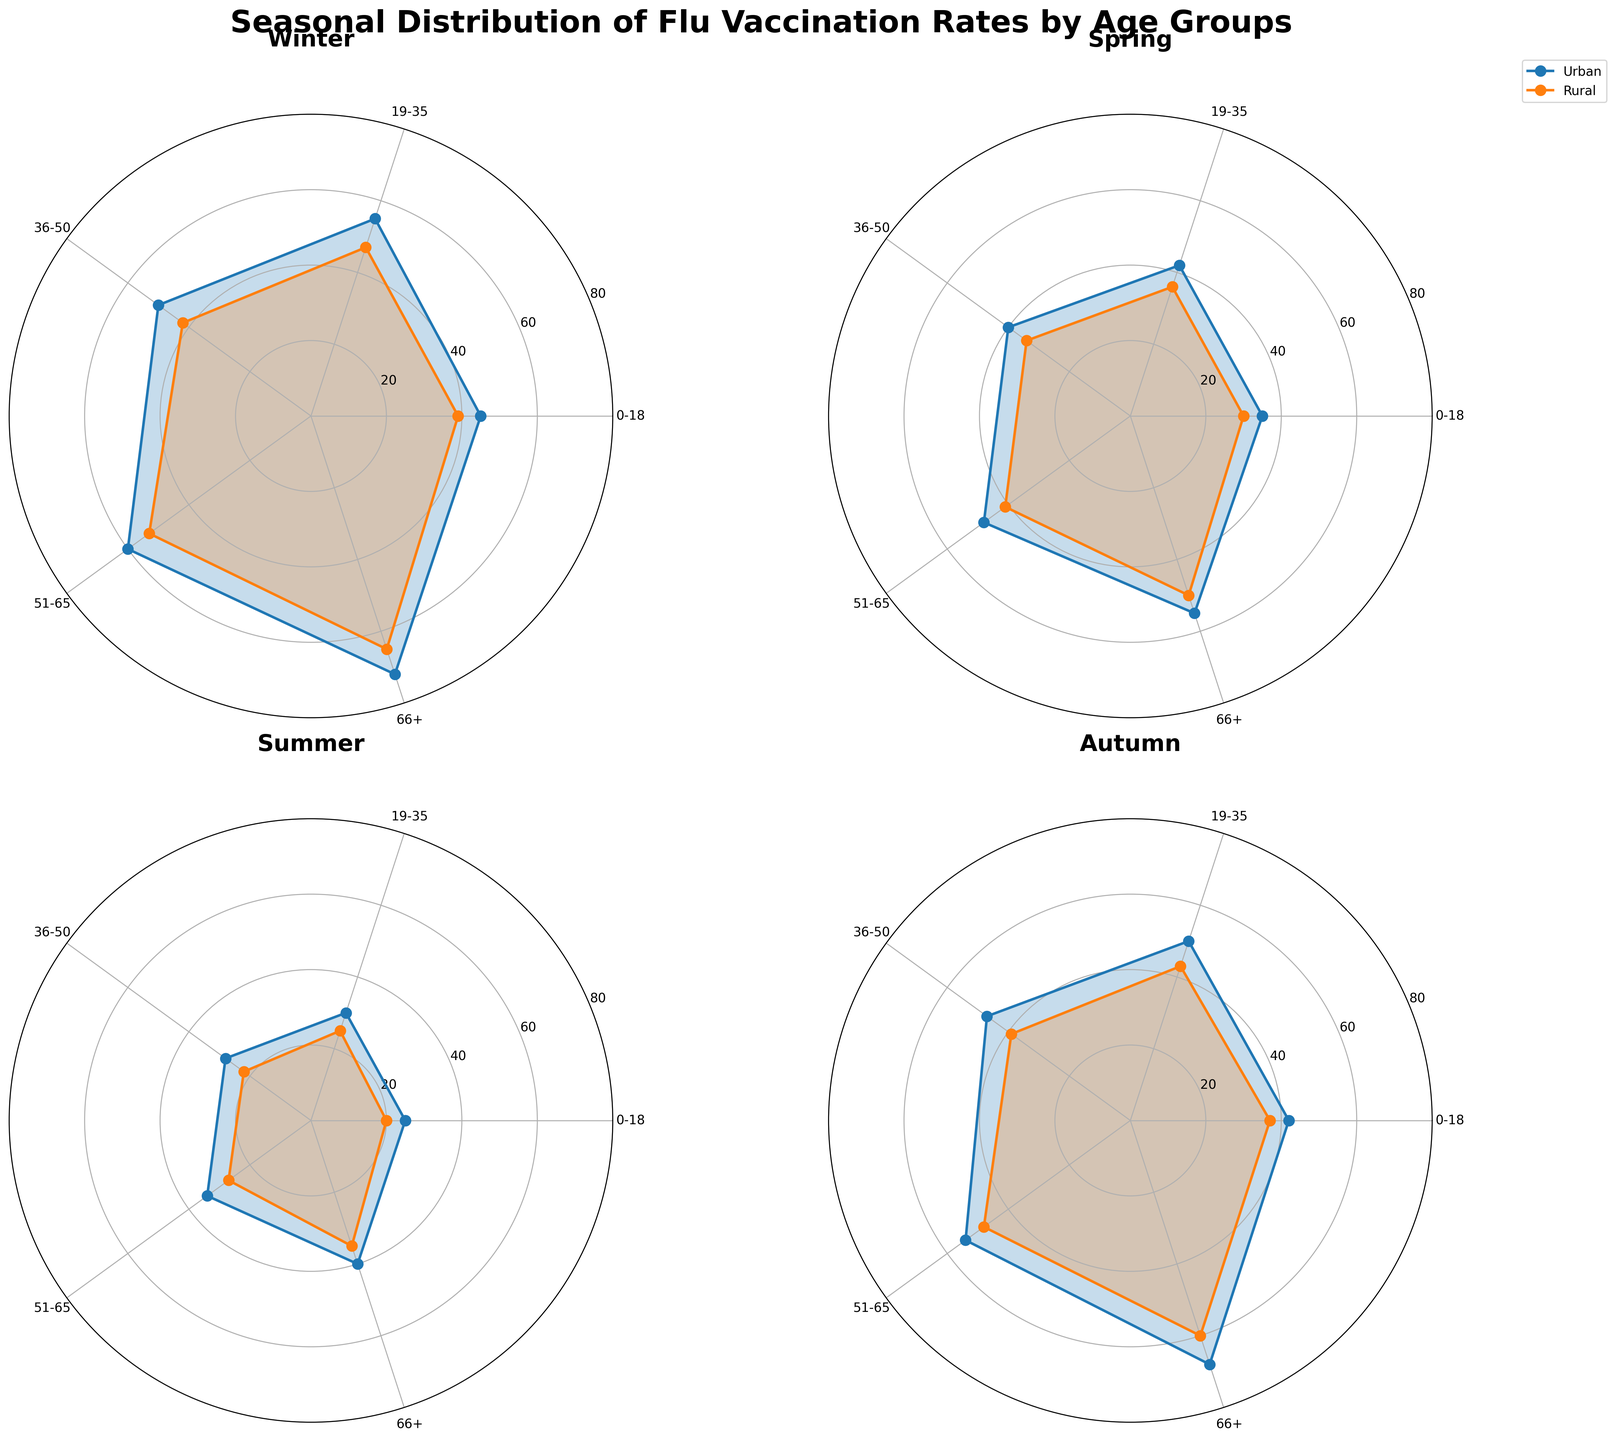What seasons are included in the rose chart? The rose chart has four subplots, each representing a different season. The titles of the subplots indicate that the seasons are Winter, Spring, Summer, and Autumn.
Answer: Winter, Spring, Summer, Autumn Which age group has the highest vaccination rate in urban areas during Winter? Looking at the Winter subplot, the outermost point on the plot for Urban areas shows the highest value. This is for the age group 66+, showing the highest vaccination rate.
Answer: 66+ How does the vaccination rate for age group 0-18 in rural areas compare between Winter and Summer? Observing the radial lines representing the rural areas in the Winter and Summer subplots, the values for the age group 0-18 are at 39 and 20 respectively. The rate is higher in Winter.
Answer: Higher in Winter What is the vaccination rate for age group 51-65 in rural areas during Spring? The Spring subplot shows the vaccination rates for each age group. For rural areas, age group 51-65, the radial line indicates a vaccination rate of 41.
Answer: 41 What is the difference in the vaccination rates of age group 66+ between Urban and Rural areas in Autumn? In the Autumn subplot, the radial lines for the 66+ age group show rates of 68 (Urban) and 60 (Rural). The difference is 68 - 60.
Answer: 8 Which season shows the lowest vaccination rates across all age groups and areas? Summarizing the radial lengths across all age groups and areas (Urban and Rural) in each subplot, the Summer subplot shows the shortest radial lengths overall, indicating the lowest vaccination rates.
Answer: Summer For the age group 19-35, does the vaccination rate ever surpass 50? If so, in which scenarios? By inspecting the radial lines for the age group 19-35 across the four seasons for both Urban and Rural areas, the Winter subplot for Urban area is the only instance where the vaccination rate exceeds 50, showing a rate of 55.
Answer: Yes, Winter Urban In which season is the vaccination rate for age group 36-50 in urban areas closest to the rural area rate? Checking each subplot, the values for age group 36-50 are compared. In Winter, the rates are 50 (Urban) and 42 (Rural); in Spring, they are 40 (Urban) and 34 (Rural); in Summer, they are 28 (Urban) and 22 (Rural); in Autumn, they are 47 (Urban) and 39 (Rural). The smallest difference is in Spring (40 - 34).
Answer: Spring 